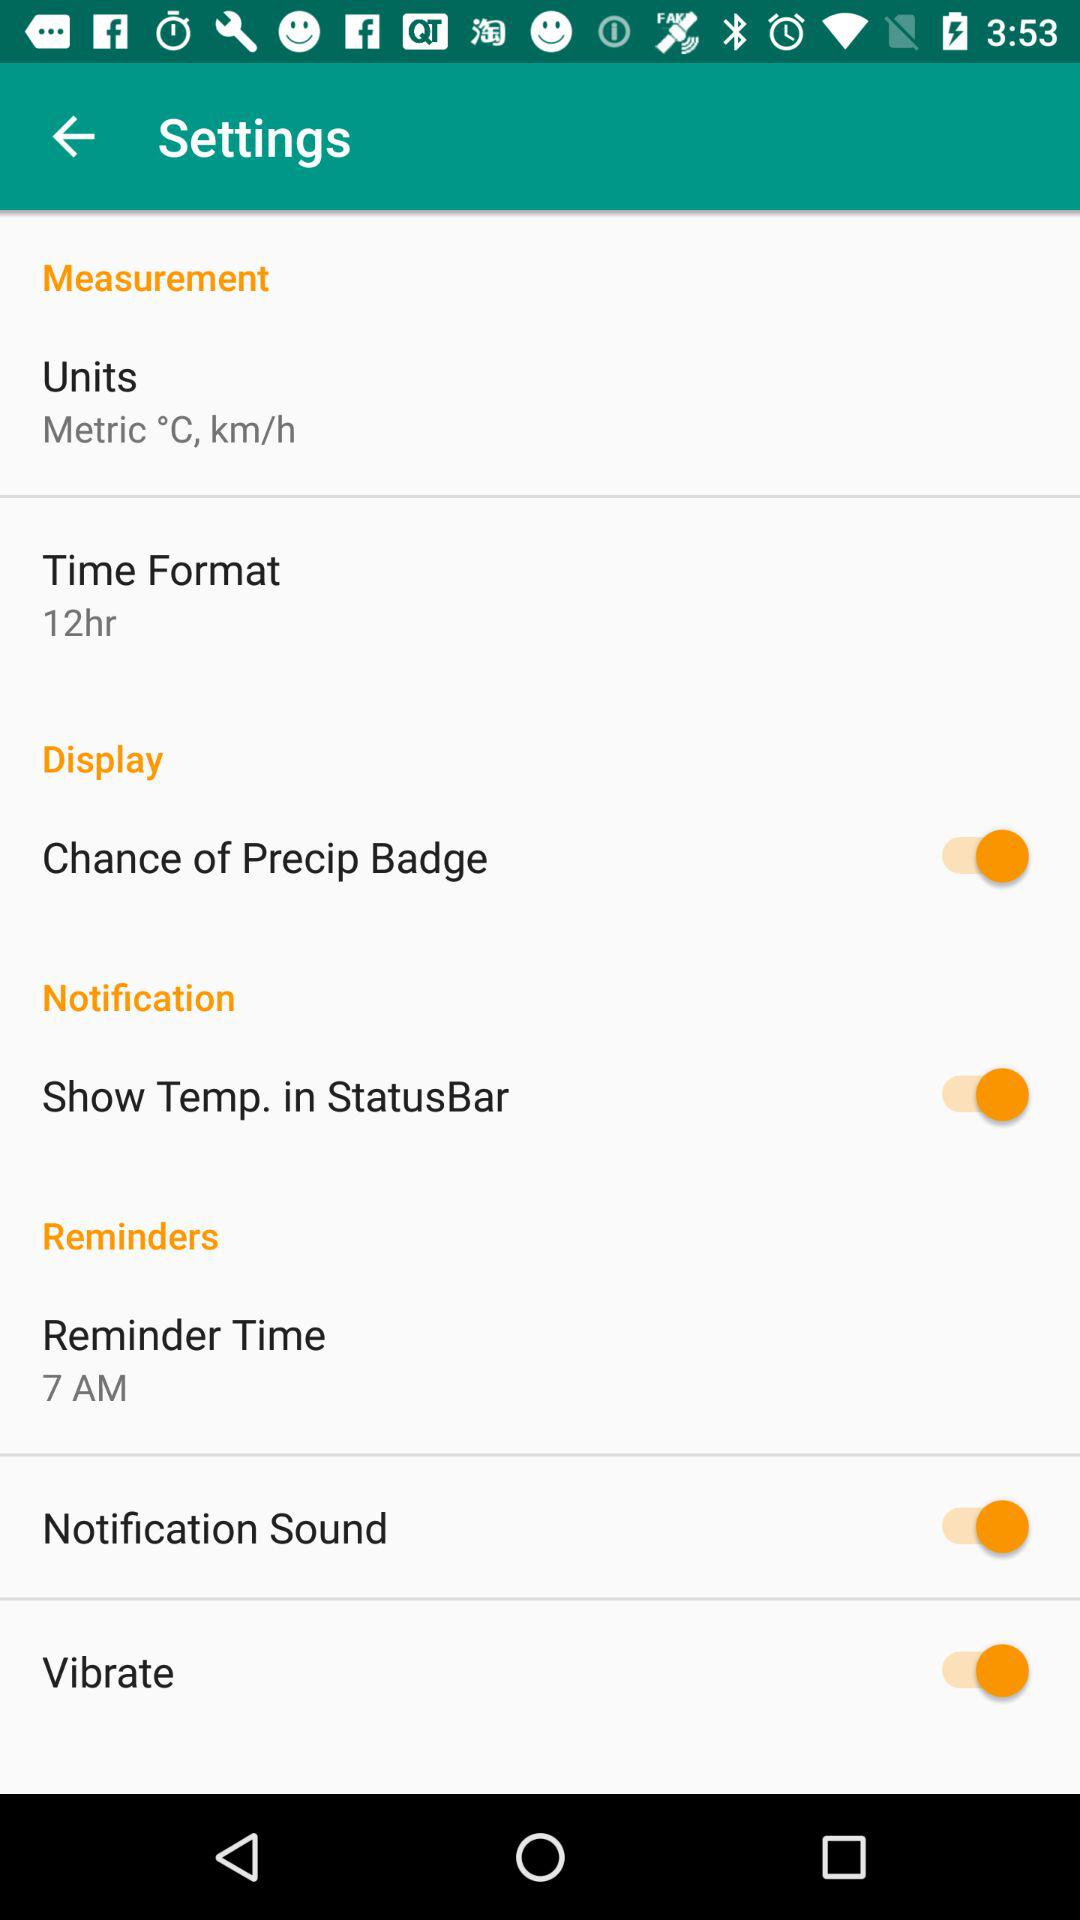Which time format is selected? The selected time format is 12 hours. 